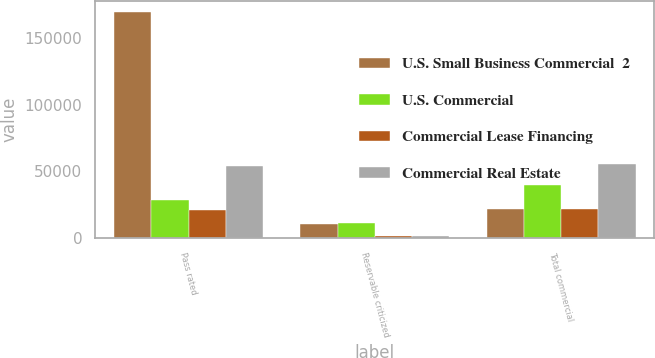Convert chart to OTSL. <chart><loc_0><loc_0><loc_500><loc_500><stacked_bar_chart><ecel><fcel>Pass rated<fcel>Reservable criticized<fcel>Total commercial<nl><fcel>U.S. Small Business Commercial  2<fcel>169599<fcel>10349<fcel>21989<nl><fcel>U.S. Commercial<fcel>28602<fcel>10994<fcel>39596<nl><fcel>Commercial Lease Financing<fcel>20850<fcel>1139<fcel>21989<nl><fcel>Commercial Real Estate<fcel>53945<fcel>1473<fcel>55418<nl></chart> 